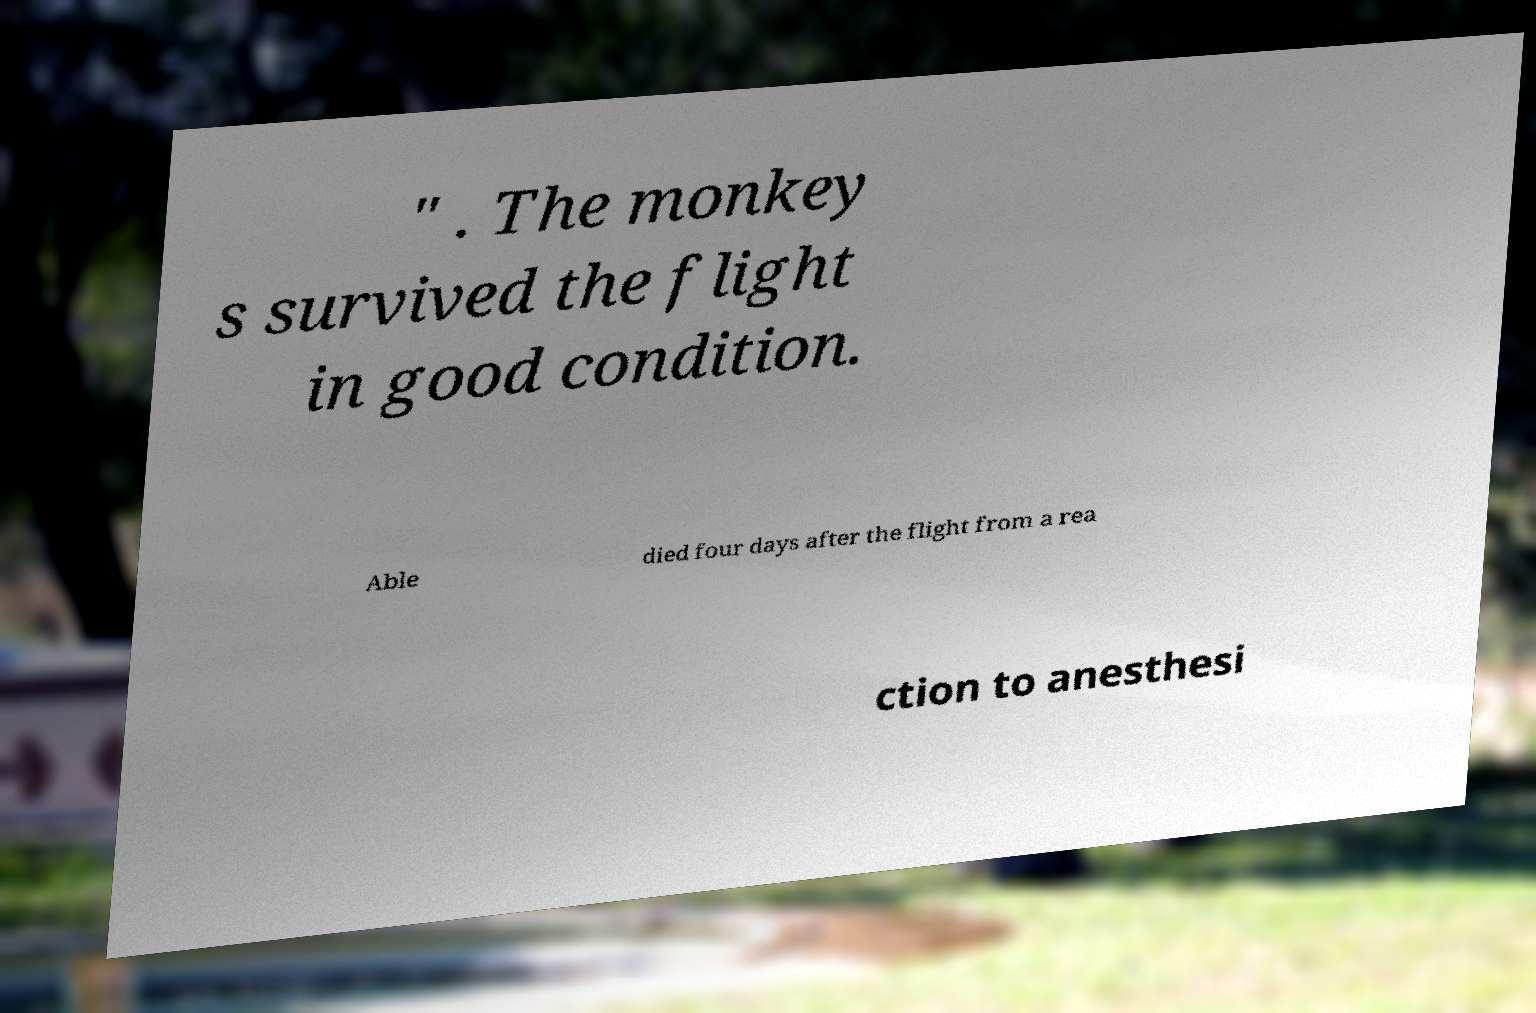For documentation purposes, I need the text within this image transcribed. Could you provide that? " . The monkey s survived the flight in good condition. Able died four days after the flight from a rea ction to anesthesi 